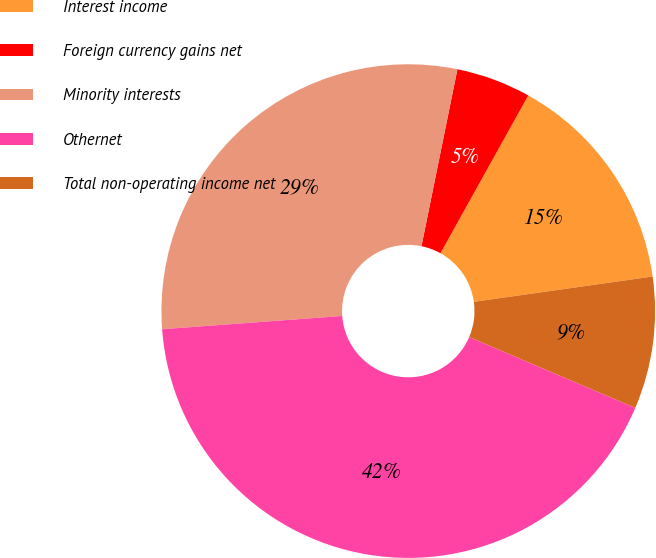<chart> <loc_0><loc_0><loc_500><loc_500><pie_chart><fcel>Interest income<fcel>Foreign currency gains net<fcel>Minority interests<fcel>Othernet<fcel>Total non-operating income net<nl><fcel>14.68%<fcel>4.89%<fcel>29.36%<fcel>42.41%<fcel>8.65%<nl></chart> 